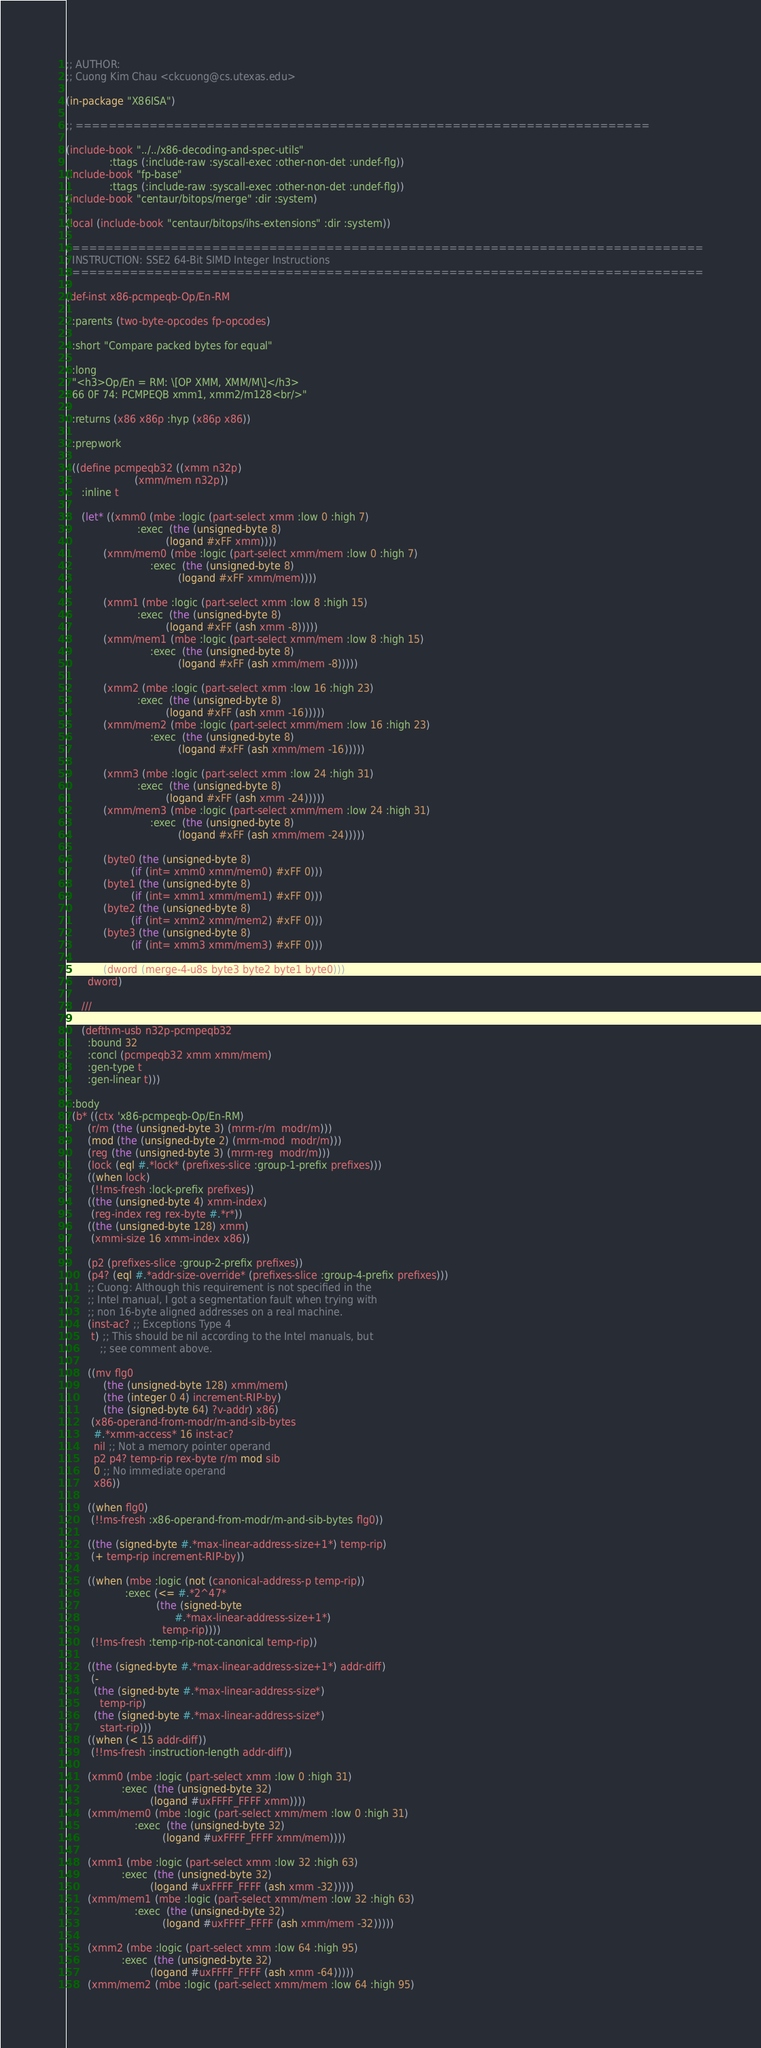<code> <loc_0><loc_0><loc_500><loc_500><_Lisp_>;; AUTHOR:
;; Cuong Kim Chau <ckcuong@cs.utexas.edu>

(in-package "X86ISA")

;; ======================================================================

(include-book "../../x86-decoding-and-spec-utils"
              :ttags (:include-raw :syscall-exec :other-non-det :undef-flg))
(include-book "fp-base"
              :ttags (:include-raw :syscall-exec :other-non-det :undef-flg))
(include-book "centaur/bitops/merge" :dir :system)

(local (include-book "centaur/bitops/ihs-extensions" :dir :system))

; =============================================================================
; INSTRUCTION: SSE2 64-Bit SIMD Integer Instructions
; =============================================================================

(def-inst x86-pcmpeqb-Op/En-RM

  :parents (two-byte-opcodes fp-opcodes)

  :short "Compare packed bytes for equal"

  :long
  "<h3>Op/En = RM: \[OP XMM, XMM/M\]</h3>
  66 0F 74: PCMPEQB xmm1, xmm2/m128<br/>"

  :returns (x86 x86p :hyp (x86p x86))

  :prepwork

  ((define pcmpeqb32 ((xmm n32p)
                      (xmm/mem n32p))
     :inline t

     (let* ((xmm0 (mbe :logic (part-select xmm :low 0 :high 7)
                       :exec  (the (unsigned-byte 8)
                                (logand #xFF xmm))))
            (xmm/mem0 (mbe :logic (part-select xmm/mem :low 0 :high 7)
                           :exec  (the (unsigned-byte 8)
                                    (logand #xFF xmm/mem))))

            (xmm1 (mbe :logic (part-select xmm :low 8 :high 15)
                       :exec  (the (unsigned-byte 8)
                                (logand #xFF (ash xmm -8)))))
            (xmm/mem1 (mbe :logic (part-select xmm/mem :low 8 :high 15)
                           :exec  (the (unsigned-byte 8)
                                    (logand #xFF (ash xmm/mem -8)))))

            (xmm2 (mbe :logic (part-select xmm :low 16 :high 23)
                       :exec  (the (unsigned-byte 8)
                                (logand #xFF (ash xmm -16)))))
            (xmm/mem2 (mbe :logic (part-select xmm/mem :low 16 :high 23)
                           :exec  (the (unsigned-byte 8)
                                    (logand #xFF (ash xmm/mem -16)))))

            (xmm3 (mbe :logic (part-select xmm :low 24 :high 31)
                       :exec  (the (unsigned-byte 8)
                                (logand #xFF (ash xmm -24)))))
            (xmm/mem3 (mbe :logic (part-select xmm/mem :low 24 :high 31)
                           :exec  (the (unsigned-byte 8)
                                    (logand #xFF (ash xmm/mem -24)))))

            (byte0 (the (unsigned-byte 8)
                     (if (int= xmm0 xmm/mem0) #xFF 0)))
            (byte1 (the (unsigned-byte 8)
                     (if (int= xmm1 xmm/mem1) #xFF 0)))
            (byte2 (the (unsigned-byte 8)
                     (if (int= xmm2 xmm/mem2) #xFF 0)))
            (byte3 (the (unsigned-byte 8)
                     (if (int= xmm3 xmm/mem3) #xFF 0)))

            (dword (merge-4-u8s byte3 byte2 byte1 byte0)))
       dword)

     ///

     (defthm-usb n32p-pcmpeqb32
       :bound 32
       :concl (pcmpeqb32 xmm xmm/mem)
       :gen-type t
       :gen-linear t)))

  :body
  (b* ((ctx 'x86-pcmpeqb-Op/En-RM)
       (r/m (the (unsigned-byte 3) (mrm-r/m  modr/m)))
       (mod (the (unsigned-byte 2) (mrm-mod  modr/m)))
       (reg (the (unsigned-byte 3) (mrm-reg  modr/m)))
       (lock (eql #.*lock* (prefixes-slice :group-1-prefix prefixes)))
       ((when lock)
        (!!ms-fresh :lock-prefix prefixes))
       ((the (unsigned-byte 4) xmm-index)
        (reg-index reg rex-byte #.*r*))
       ((the (unsigned-byte 128) xmm)
        (xmmi-size 16 xmm-index x86))

       (p2 (prefixes-slice :group-2-prefix prefixes))
       (p4? (eql #.*addr-size-override* (prefixes-slice :group-4-prefix prefixes)))
       ;; Cuong: Although this requirement is not specified in the
       ;; Intel manual, I got a segmentation fault when trying with
       ;; non 16-byte aligned addresses on a real machine.
       (inst-ac? ;; Exceptions Type 4
        t) ;; This should be nil according to the Intel manuals, but
           ;; see comment above.

       ((mv flg0
            (the (unsigned-byte 128) xmm/mem)
            (the (integer 0 4) increment-RIP-by)
            (the (signed-byte 64) ?v-addr) x86)
        (x86-operand-from-modr/m-and-sib-bytes
         #.*xmm-access* 16 inst-ac?
         nil ;; Not a memory pointer operand
         p2 p4? temp-rip rex-byte r/m mod sib
         0 ;; No immediate operand
         x86))

       ((when flg0)
        (!!ms-fresh :x86-operand-from-modr/m-and-sib-bytes flg0))

       ((the (signed-byte #.*max-linear-address-size+1*) temp-rip)
        (+ temp-rip increment-RIP-by))

       ((when (mbe :logic (not (canonical-address-p temp-rip))
                   :exec (<= #.*2^47*
                             (the (signed-byte
                                   #.*max-linear-address-size+1*)
                               temp-rip))))
        (!!ms-fresh :temp-rip-not-canonical temp-rip))

       ((the (signed-byte #.*max-linear-address-size+1*) addr-diff)
        (-
         (the (signed-byte #.*max-linear-address-size*)
           temp-rip)
         (the (signed-byte #.*max-linear-address-size*)
           start-rip)))
       ((when (< 15 addr-diff))
        (!!ms-fresh :instruction-length addr-diff))

       (xmm0 (mbe :logic (part-select xmm :low 0 :high 31)
                  :exec  (the (unsigned-byte 32)
                           (logand #uxFFFF_FFFF xmm))))
       (xmm/mem0 (mbe :logic (part-select xmm/mem :low 0 :high 31)
                      :exec  (the (unsigned-byte 32)
                               (logand #uxFFFF_FFFF xmm/mem))))

       (xmm1 (mbe :logic (part-select xmm :low 32 :high 63)
                  :exec  (the (unsigned-byte 32)
                           (logand #uxFFFF_FFFF (ash xmm -32)))))
       (xmm/mem1 (mbe :logic (part-select xmm/mem :low 32 :high 63)
                      :exec  (the (unsigned-byte 32)
                               (logand #uxFFFF_FFFF (ash xmm/mem -32)))))

       (xmm2 (mbe :logic (part-select xmm :low 64 :high 95)
                  :exec  (the (unsigned-byte 32)
                           (logand #uxFFFF_FFFF (ash xmm -64)))))
       (xmm/mem2 (mbe :logic (part-select xmm/mem :low 64 :high 95)</code> 